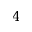<formula> <loc_0><loc_0><loc_500><loc_500>4</formula> 